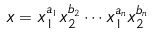<formula> <loc_0><loc_0><loc_500><loc_500>x = x _ { 1 } ^ { a _ { 1 } } x _ { 2 } ^ { b _ { 2 } } \cdots x _ { 1 } ^ { a _ { n } } x _ { 2 } ^ { b _ { n } }</formula> 